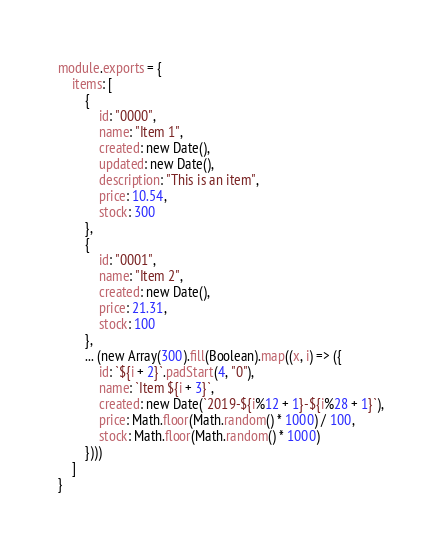Convert code to text. <code><loc_0><loc_0><loc_500><loc_500><_JavaScript_>module.exports = {
	items: [
		{
			id: "0000",
			name: "Item 1",
			created: new Date(),
			updated: new Date(),
			description: "This is an item",
			price: 10.54,
			stock: 300
		},
		{
			id: "0001",
			name: "Item 2",
			created: new Date(),
			price: 21.31,
			stock: 100
		},
		... (new Array(300).fill(Boolean).map((x, i) => ({
			id: `${i + 2}`.padStart(4, "0"),
			name: `Item ${i + 3}`,
			created: new Date(`2019-${i%12 + 1}-${i%28 + 1}`),
			price: Math.floor(Math.random() * 1000) / 100,
			stock: Math.floor(Math.random() * 1000)
		})))
	]
}
</code> 